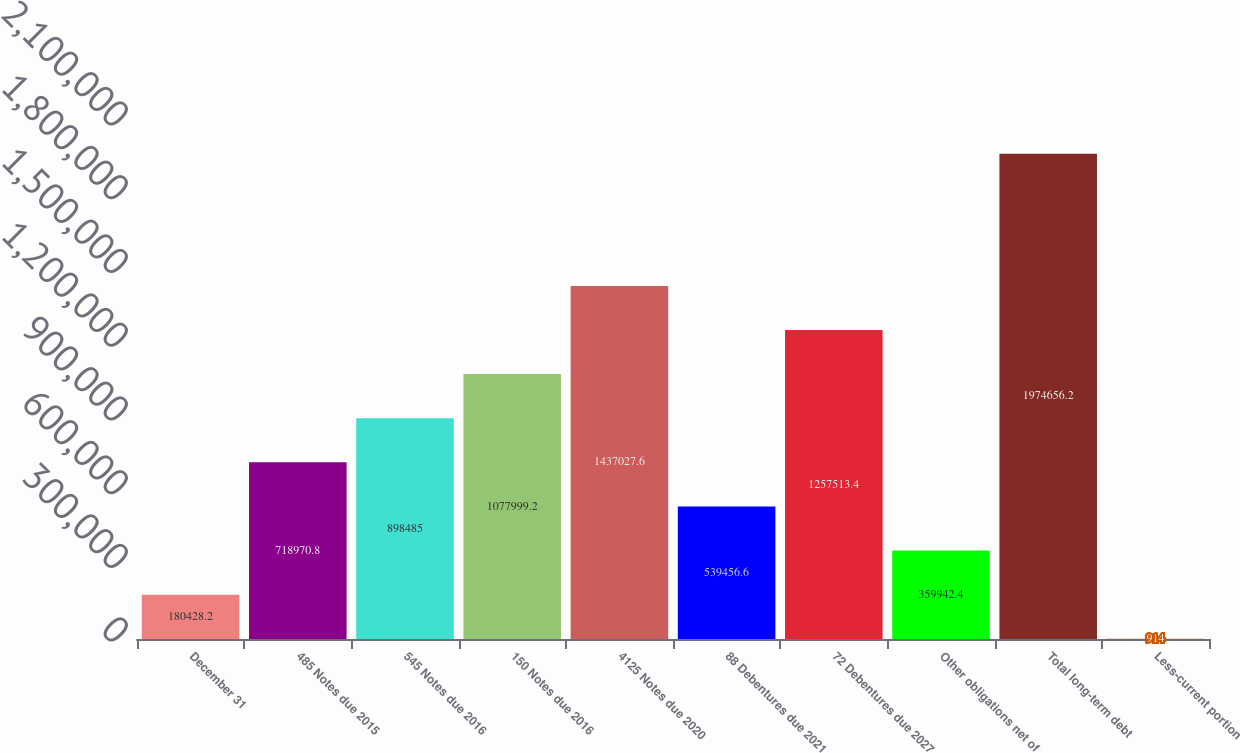<chart> <loc_0><loc_0><loc_500><loc_500><bar_chart><fcel>December 31<fcel>485 Notes due 2015<fcel>545 Notes due 2016<fcel>150 Notes due 2016<fcel>4125 Notes due 2020<fcel>88 Debentures due 2021<fcel>72 Debentures due 2027<fcel>Other obligations net of<fcel>Total long-term debt<fcel>Less-current portion<nl><fcel>180428<fcel>718971<fcel>898485<fcel>1.078e+06<fcel>1.43703e+06<fcel>539457<fcel>1.25751e+06<fcel>359942<fcel>1.97466e+06<fcel>914<nl></chart> 